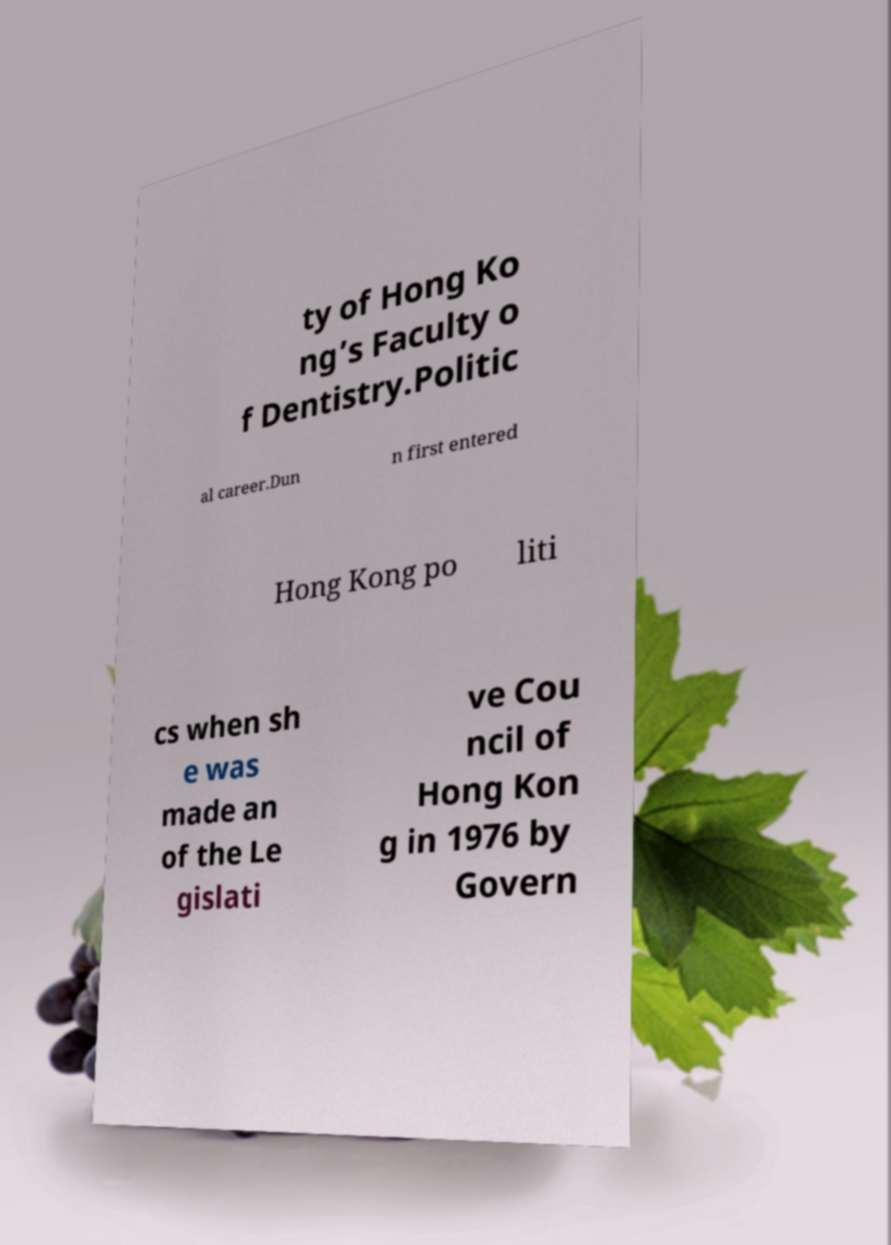Please read and relay the text visible in this image. What does it say? ty of Hong Ko ng’s Faculty o f Dentistry.Politic al career.Dun n first entered Hong Kong po liti cs when sh e was made an of the Le gislati ve Cou ncil of Hong Kon g in 1976 by Govern 